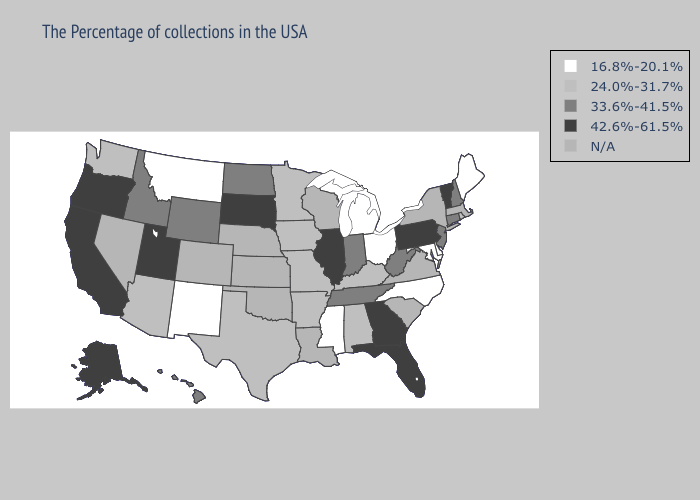Among the states that border South Carolina , which have the lowest value?
Concise answer only. North Carolina. Does Kentucky have the highest value in the South?
Answer briefly. No. Does New Mexico have the lowest value in the USA?
Keep it brief. Yes. What is the value of Arizona?
Answer briefly. 24.0%-31.7%. Does Pennsylvania have the lowest value in the USA?
Quick response, please. No. Does Rhode Island have the lowest value in the Northeast?
Write a very short answer. No. Name the states that have a value in the range N/A?
Be succinct. Massachusetts, New York, Virginia, South Carolina, Wisconsin, Louisiana, Kansas, Nebraska, Oklahoma, Colorado, Nevada. Name the states that have a value in the range N/A?
Answer briefly. Massachusetts, New York, Virginia, South Carolina, Wisconsin, Louisiana, Kansas, Nebraska, Oklahoma, Colorado, Nevada. Name the states that have a value in the range N/A?
Quick response, please. Massachusetts, New York, Virginia, South Carolina, Wisconsin, Louisiana, Kansas, Nebraska, Oklahoma, Colorado, Nevada. Does Ohio have the lowest value in the MidWest?
Keep it brief. Yes. What is the value of Nebraska?
Answer briefly. N/A. How many symbols are there in the legend?
Give a very brief answer. 5. Which states have the lowest value in the MidWest?
Give a very brief answer. Ohio, Michigan. 